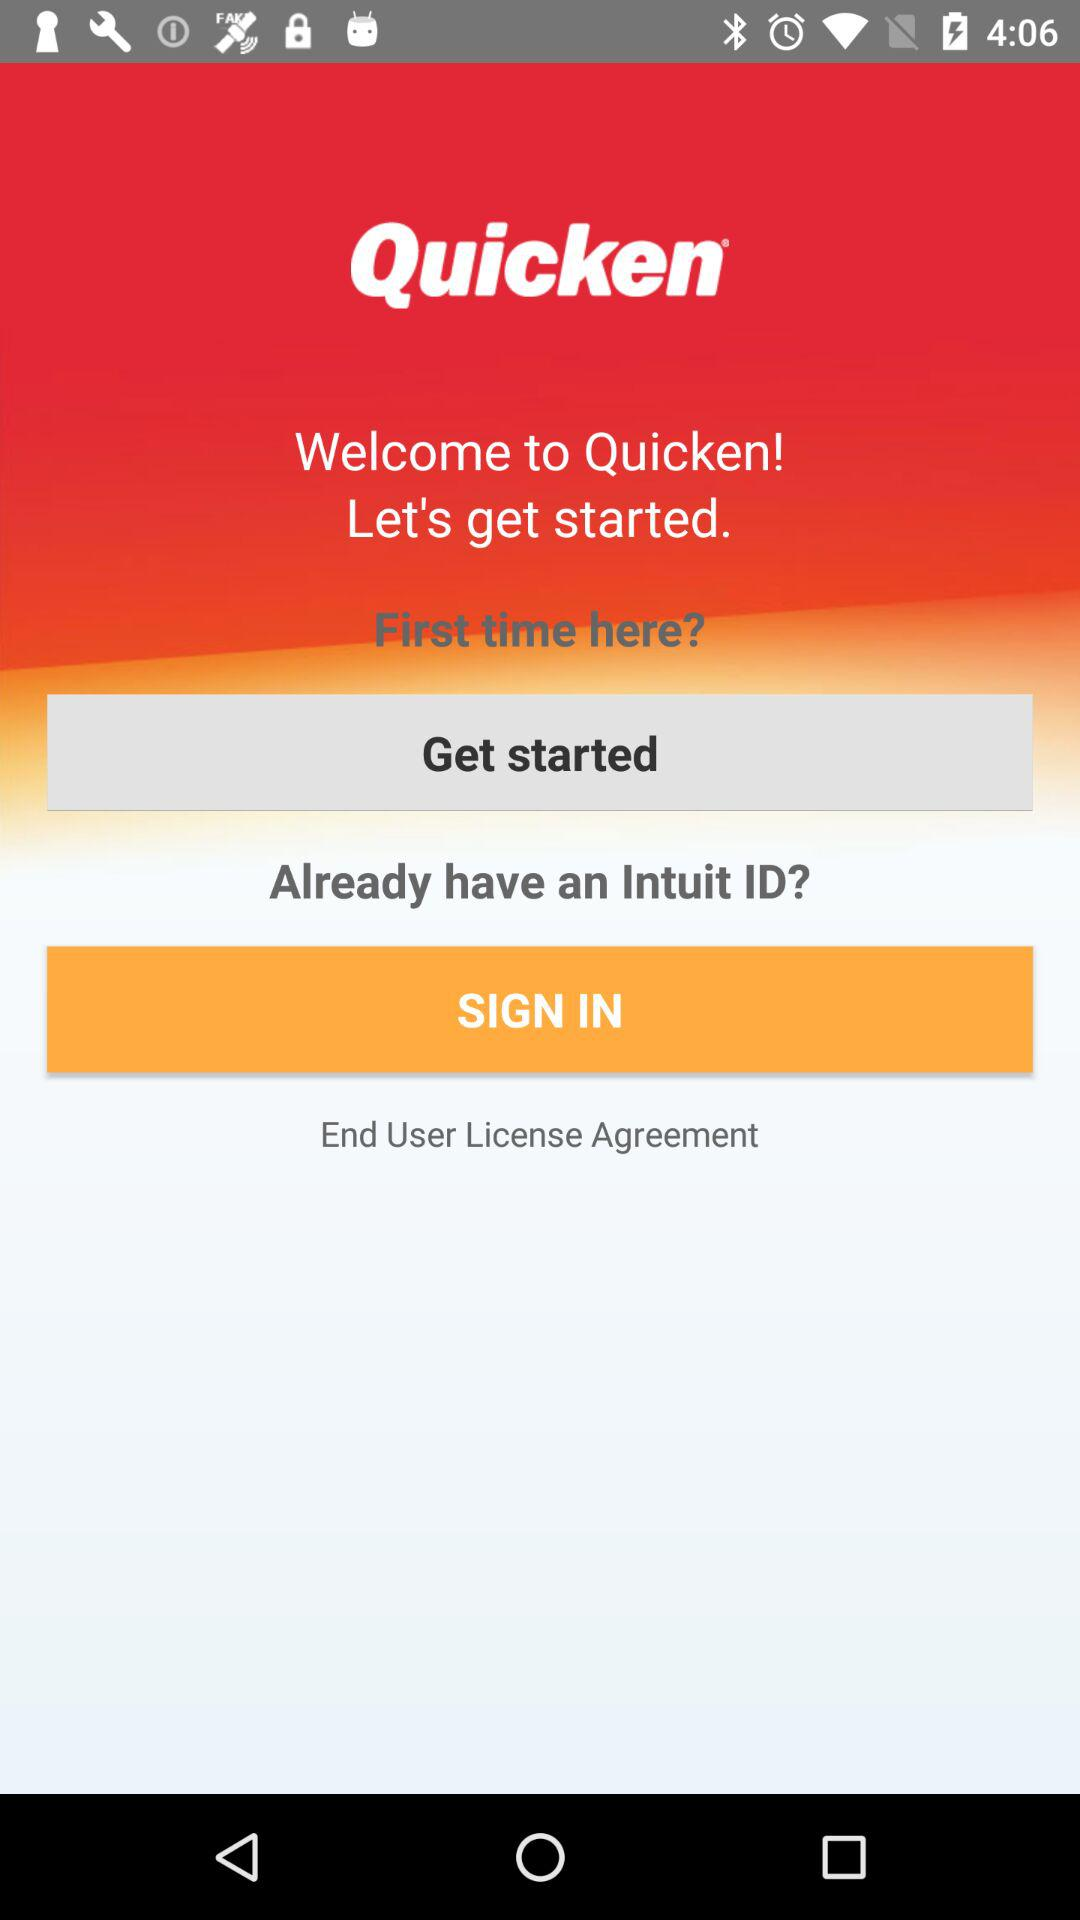What is the application name? The application name is "Quicken". 